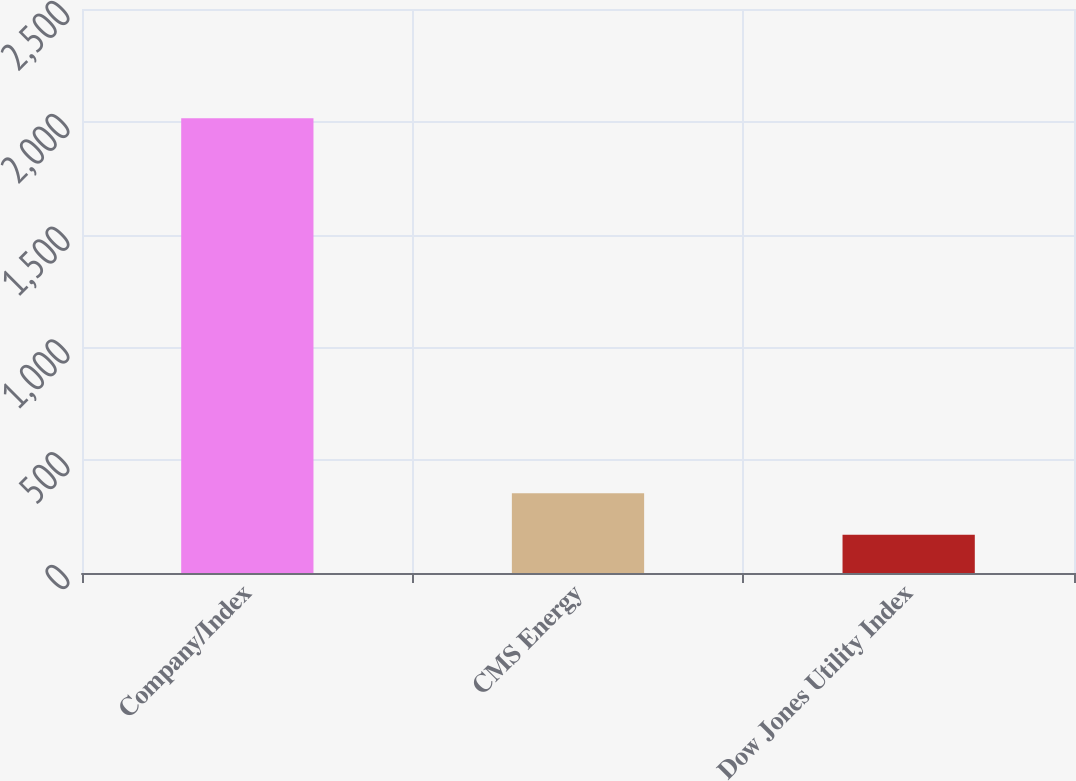Convert chart to OTSL. <chart><loc_0><loc_0><loc_500><loc_500><bar_chart><fcel>Company/Index<fcel>CMS Energy<fcel>Dow Jones Utility Index<nl><fcel>2016<fcel>353.7<fcel>169<nl></chart> 